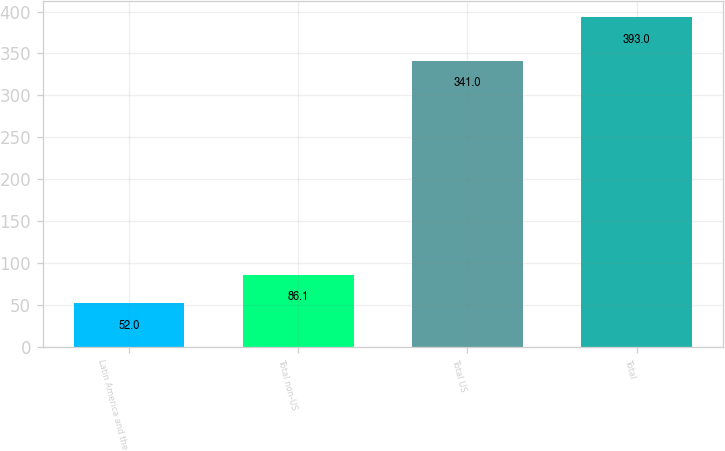<chart> <loc_0><loc_0><loc_500><loc_500><bar_chart><fcel>Latin America and the<fcel>Total non-US<fcel>Total US<fcel>Total<nl><fcel>52<fcel>86.1<fcel>341<fcel>393<nl></chart> 